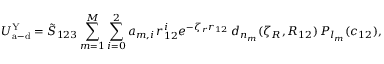<formula> <loc_0><loc_0><loc_500><loc_500>U _ { a - d } ^ { Y } = \tilde { S } _ { 1 2 3 } \sum _ { m = 1 } ^ { M } \sum _ { i = 0 } ^ { 2 } a _ { m , i } \, r _ { 1 2 } ^ { i } e ^ { - \zeta _ { r } r _ { 1 2 } } \, d _ { n _ { m } } ( \zeta _ { R } , R _ { 1 2 } ) \, P _ { l _ { m } } ( c _ { 1 2 } ) ,</formula> 